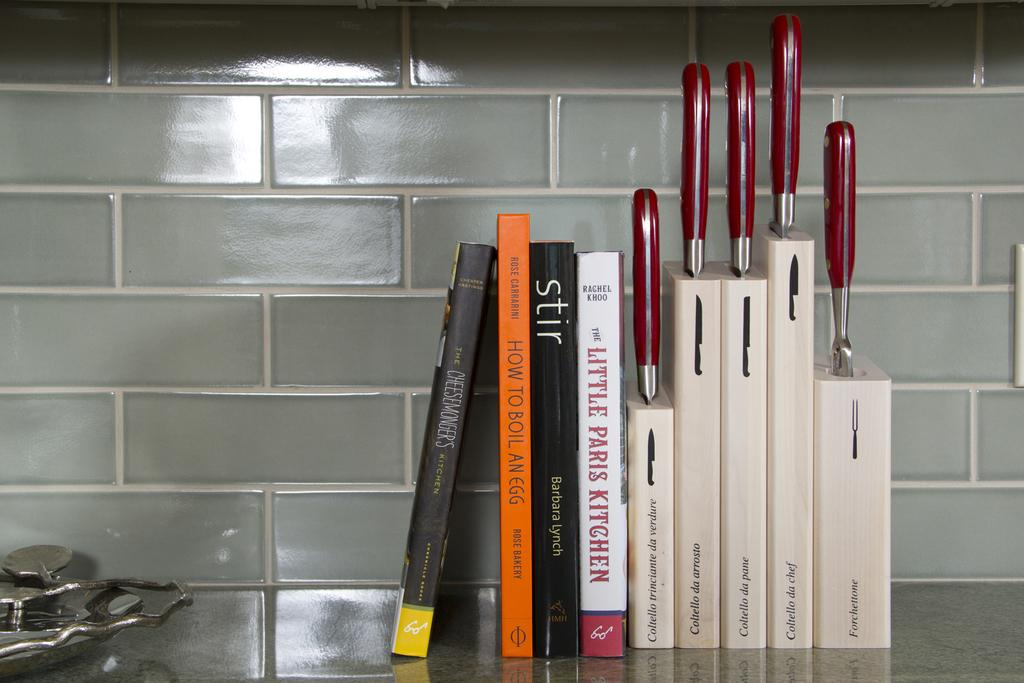Provide a one-sentence caption for the provided image. Kitchen counter with knives and a host of books such as Stir by Barbara Lynch. 